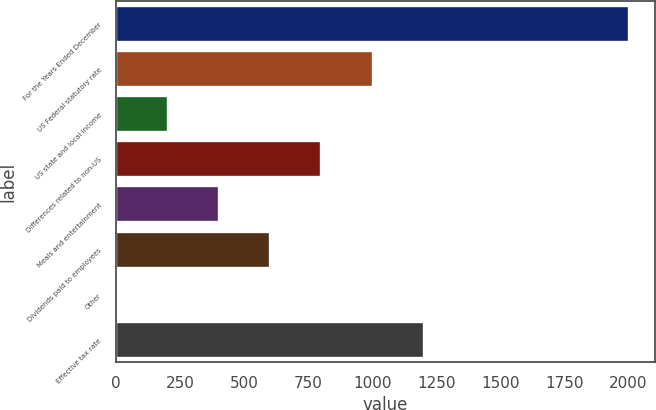Convert chart to OTSL. <chart><loc_0><loc_0><loc_500><loc_500><bar_chart><fcel>For the Years Ended December<fcel>US Federal statutory rate<fcel>US state and local income<fcel>Differences related to non-US<fcel>Meals and entertainment<fcel>Dividends paid to employees<fcel>Other<fcel>Effective tax rate<nl><fcel>2004<fcel>1002.45<fcel>201.21<fcel>802.14<fcel>401.52<fcel>601.83<fcel>0.9<fcel>1202.76<nl></chart> 